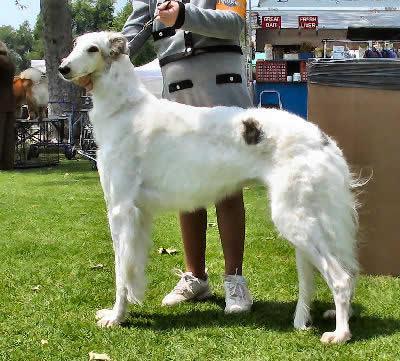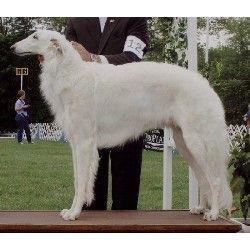The first image is the image on the left, the second image is the image on the right. Given the left and right images, does the statement "The single white dog in the image on the left is standing in a grassy area." hold true? Answer yes or no. Yes. The first image is the image on the left, the second image is the image on the right. Analyze the images presented: Is the assertion "The left image contains at least three times as many hounds as the right image." valid? Answer yes or no. No. 